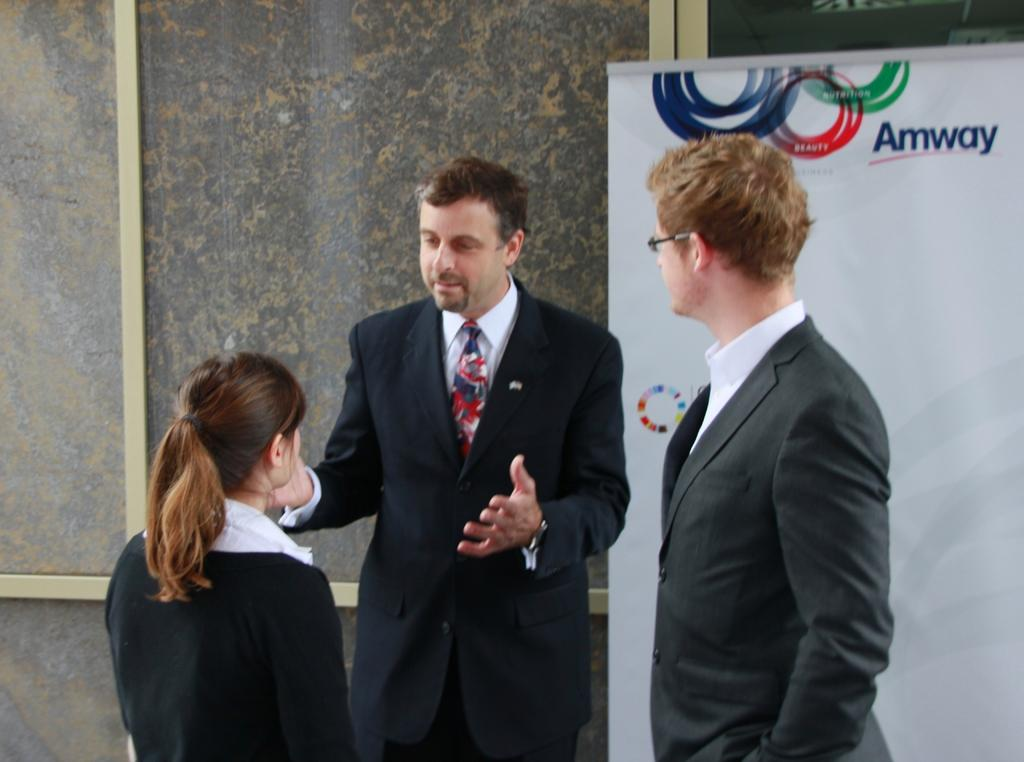What are the people in the image doing? The people in the image are standing in the center. What are the people wearing? The people are wearing coats. Can you describe any specific details about one of the people? One of the people is wearing glasses. What can be seen in the background of the image? There is a banner and a board visible in the background. What type of paper is being used to create the land in the image? There is no land present in the image, nor is there any paper being used to create it. 